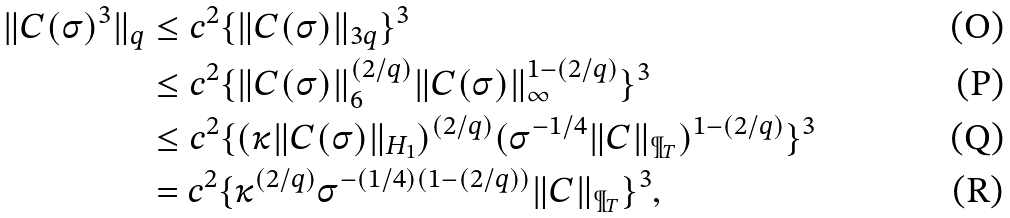Convert formula to latex. <formula><loc_0><loc_0><loc_500><loc_500>\| C ( \sigma ) ^ { 3 } \| _ { q } & \leq c ^ { 2 } \{ \| C ( \sigma ) \| _ { 3 q } \} ^ { 3 } \\ & \leq c ^ { 2 } \{ \| C ( \sigma ) \| _ { 6 } ^ { ( 2 / q ) } \| C ( \sigma ) \| _ { \infty } ^ { 1 - ( 2 / q ) } \} ^ { 3 } \\ & \leq c ^ { 2 } \{ ( \kappa \| C ( \sigma ) \| _ { H _ { 1 } } ) ^ { ( 2 / q ) } ( \sigma ^ { - 1 / 4 } \| C \| _ { \P _ { T } } ) ^ { 1 - ( 2 / q ) } \} ^ { 3 } \\ & = c ^ { 2 } \{ \kappa ^ { ( 2 / q ) } \sigma ^ { - ( 1 / 4 ) ( 1 - ( 2 / q ) ) } \| C \| _ { \P _ { T } } \} ^ { 3 } ,</formula> 